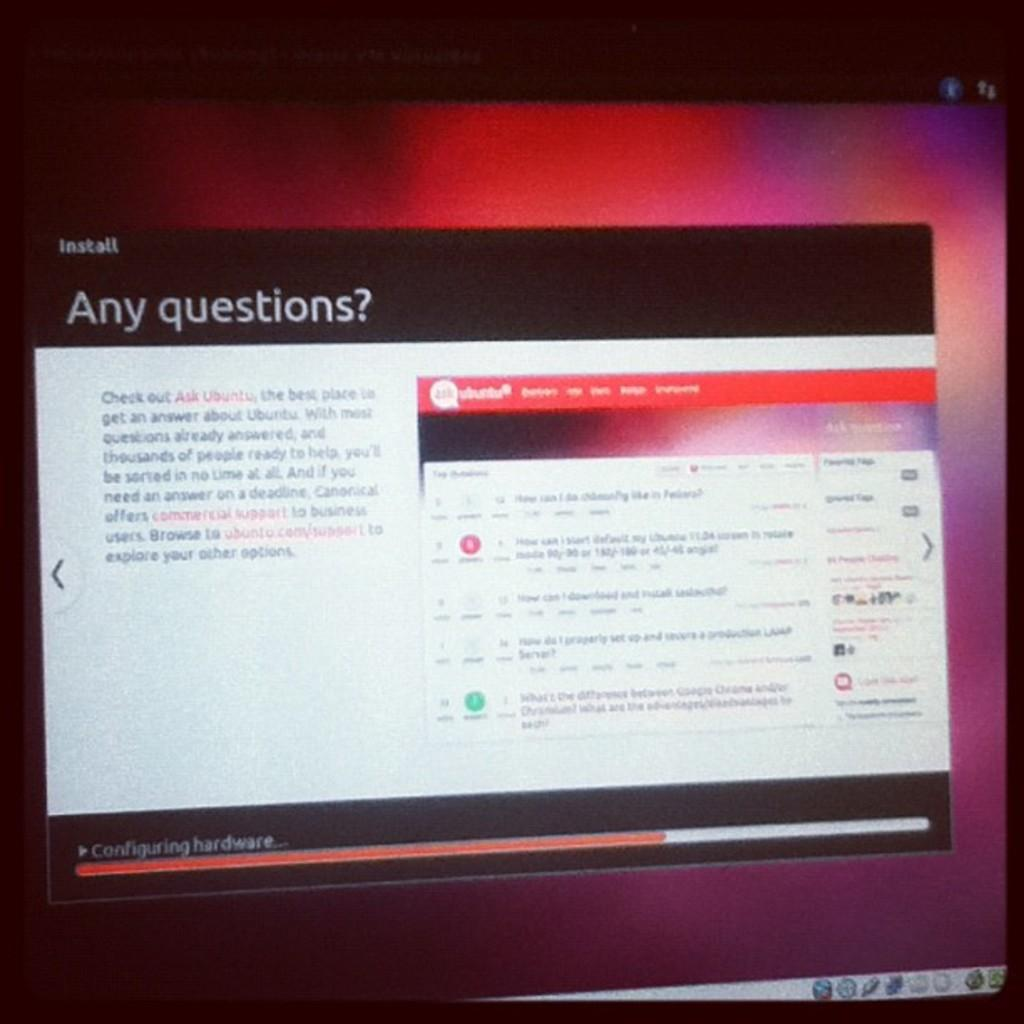<image>
Share a concise interpretation of the image provided. A computer screen with a window up saying "Any questions?" 